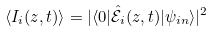Convert formula to latex. <formula><loc_0><loc_0><loc_500><loc_500>\langle I _ { i } ( z , t ) \rangle = | \langle 0 | \hat { \mathcal { E } } _ { i } ( z , t ) | \psi _ { i n } \rangle | ^ { 2 }</formula> 